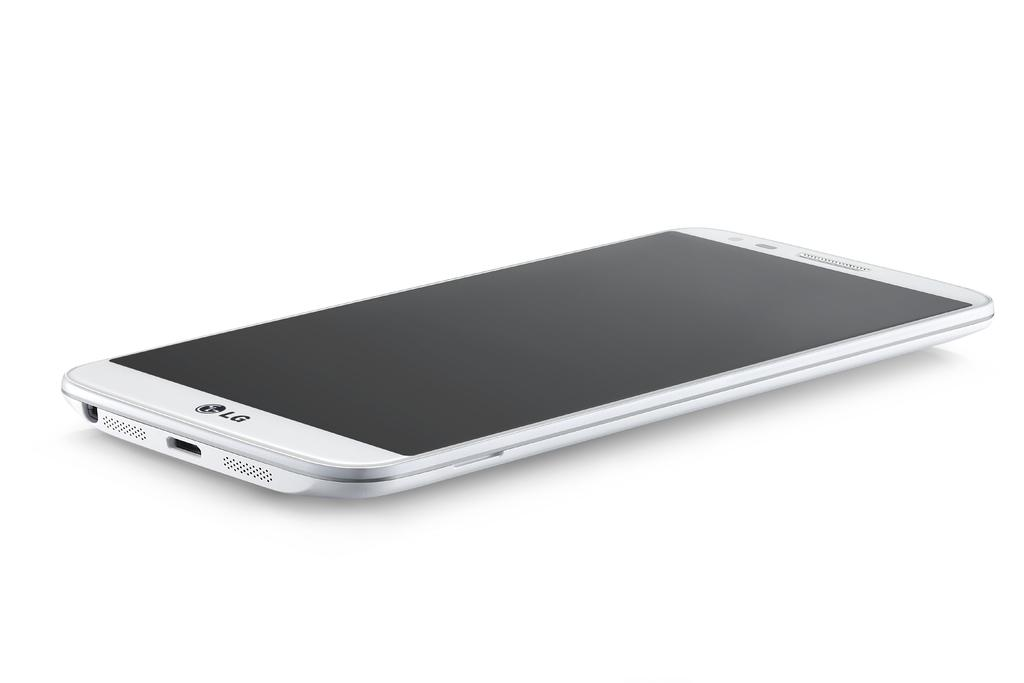<image>
Render a clear and concise summary of the photo. The phone shown sitting on a white background is an LG phone. 